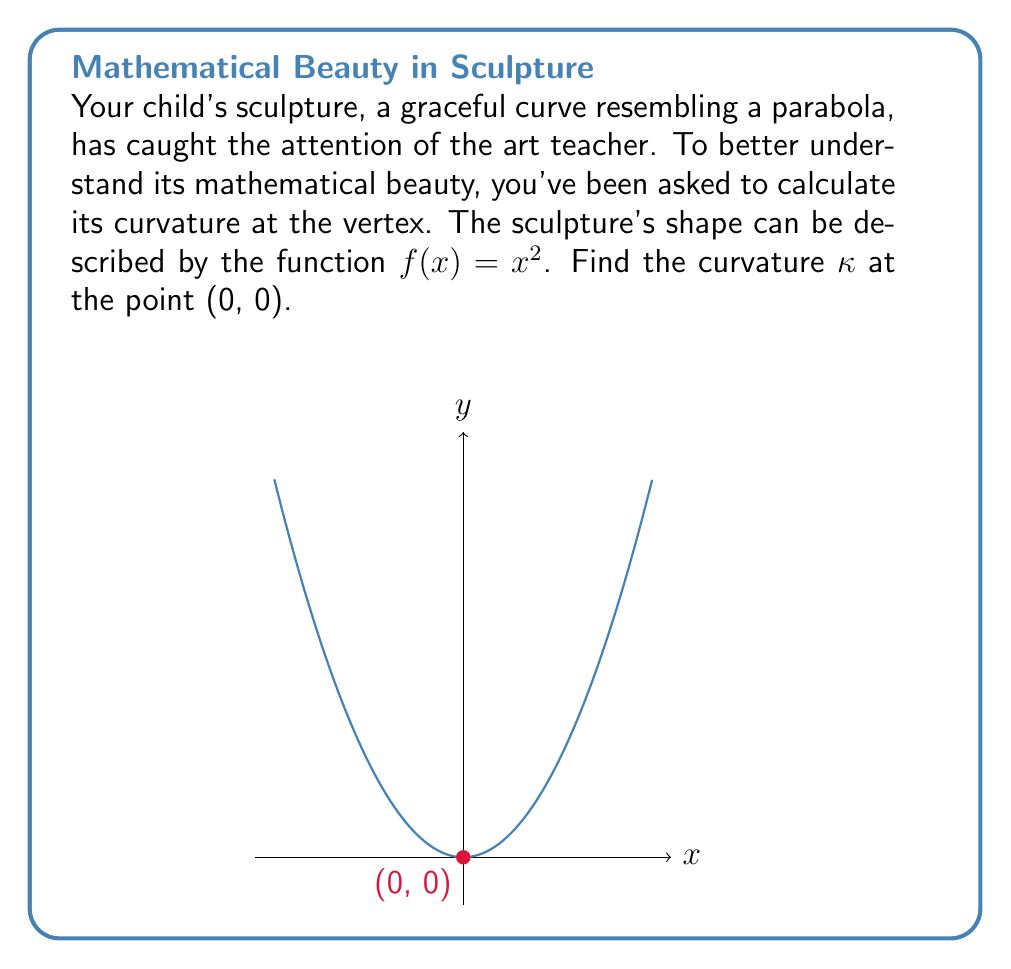Help me with this question. Let's approach this step-by-step:

1) The curvature $\kappa$ of a function $y = f(x)$ is given by the formula:

   $$\kappa = \frac{|f''(x)|}{(1 + [f'(x)]^2)^{3/2}}$$

2) We need to find $f'(x)$ and $f''(x)$:
   
   $f(x) = x^2$
   $f'(x) = 2x$
   $f''(x) = 2$

3) At the point (0, 0), $x = 0$. Let's substitute these into our curvature formula:

   $$\kappa = \frac{|f''(0)|}{(1 + [f'(0)]^2)^{3/2}}$$

4) Calculate $f'(0)$ and $f''(0)$:
   
   $f'(0) = 2(0) = 0$
   $f''(0) = 2$

5) Now, let's substitute these values:

   $$\kappa = \frac{|2|}{(1 + [0]^2)^{3/2}} = \frac{2}{1^{3/2}} = 2$$

Therefore, the curvature of your child's sculptural form at the vertex (0, 0) is 2.
Answer: $\kappa = 2$ 